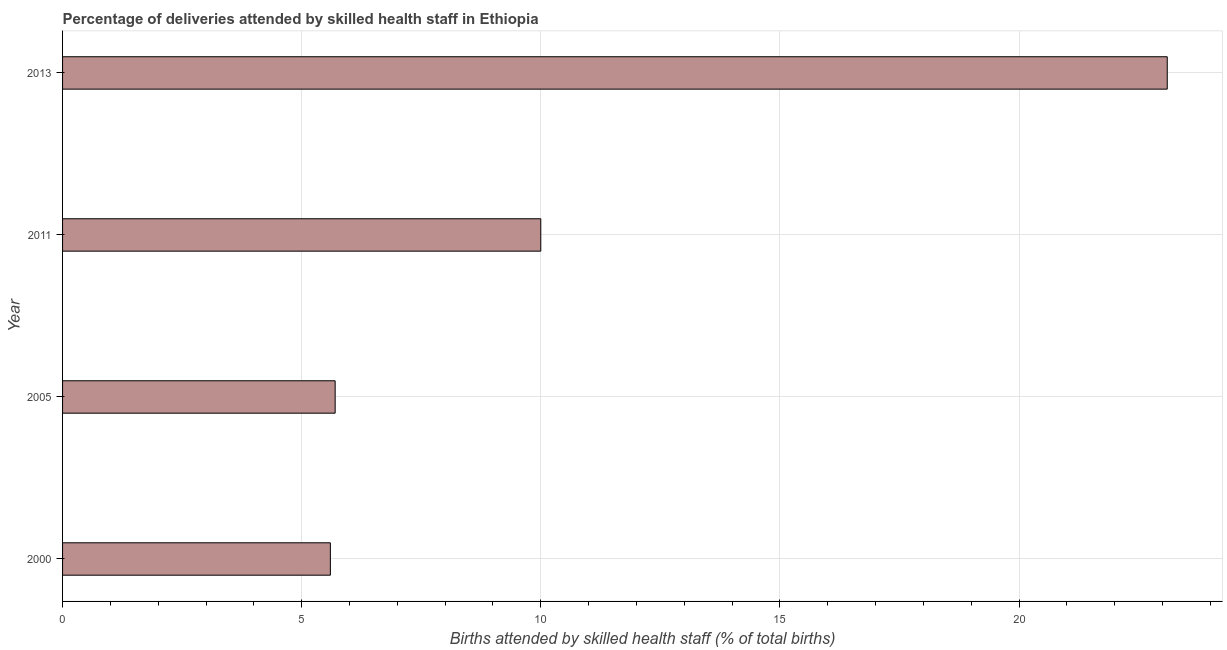Does the graph contain any zero values?
Your answer should be very brief. No. What is the title of the graph?
Offer a very short reply. Percentage of deliveries attended by skilled health staff in Ethiopia. What is the label or title of the X-axis?
Keep it short and to the point. Births attended by skilled health staff (% of total births). What is the number of births attended by skilled health staff in 2013?
Your response must be concise. 23.1. Across all years, what is the maximum number of births attended by skilled health staff?
Offer a terse response. 23.1. Across all years, what is the minimum number of births attended by skilled health staff?
Provide a short and direct response. 5.6. In which year was the number of births attended by skilled health staff minimum?
Ensure brevity in your answer.  2000. What is the sum of the number of births attended by skilled health staff?
Provide a succinct answer. 44.4. What is the difference between the number of births attended by skilled health staff in 2000 and 2005?
Keep it short and to the point. -0.1. What is the median number of births attended by skilled health staff?
Offer a very short reply. 7.85. In how many years, is the number of births attended by skilled health staff greater than 22 %?
Provide a succinct answer. 1. What is the ratio of the number of births attended by skilled health staff in 2000 to that in 2005?
Ensure brevity in your answer.  0.98. Is the number of births attended by skilled health staff in 2005 less than that in 2013?
Your answer should be very brief. Yes. Is the sum of the number of births attended by skilled health staff in 2000 and 2005 greater than the maximum number of births attended by skilled health staff across all years?
Provide a succinct answer. No. How many bars are there?
Offer a terse response. 4. What is the Births attended by skilled health staff (% of total births) of 2011?
Offer a terse response. 10. What is the Births attended by skilled health staff (% of total births) in 2013?
Your answer should be very brief. 23.1. What is the difference between the Births attended by skilled health staff (% of total births) in 2000 and 2013?
Keep it short and to the point. -17.5. What is the difference between the Births attended by skilled health staff (% of total births) in 2005 and 2013?
Your response must be concise. -17.4. What is the difference between the Births attended by skilled health staff (% of total births) in 2011 and 2013?
Your response must be concise. -13.1. What is the ratio of the Births attended by skilled health staff (% of total births) in 2000 to that in 2011?
Ensure brevity in your answer.  0.56. What is the ratio of the Births attended by skilled health staff (% of total births) in 2000 to that in 2013?
Provide a succinct answer. 0.24. What is the ratio of the Births attended by skilled health staff (% of total births) in 2005 to that in 2011?
Your answer should be compact. 0.57. What is the ratio of the Births attended by skilled health staff (% of total births) in 2005 to that in 2013?
Your response must be concise. 0.25. What is the ratio of the Births attended by skilled health staff (% of total births) in 2011 to that in 2013?
Provide a short and direct response. 0.43. 